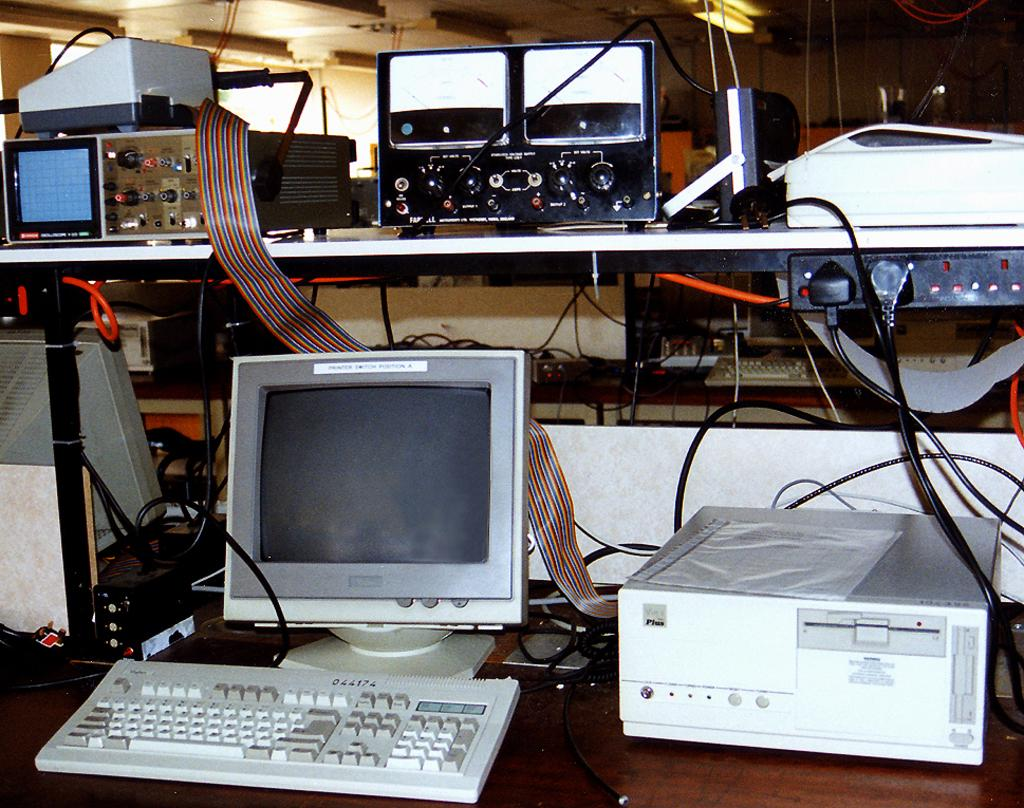What is the main subject of the image? The main subject of the image is a system. What is one component of the system? There is a keyboard in the image. What other machines are present in the image? There are other machines in the image. How are the machines connected in the image? There are wires in the image, which may connect the machines. What is the source of illumination in the image? There is a light on the top of the image. Where are the machines and system located in the image? All the elements are placed on tables. Can you see any boats in the harbor in the image? There is no harbor or boats present in the image; it features a system with machines and a keyboard. What type of trouble is the system experiencing in the image? There is no indication of trouble in the image; it simply shows a system with machines and a keyboard. 